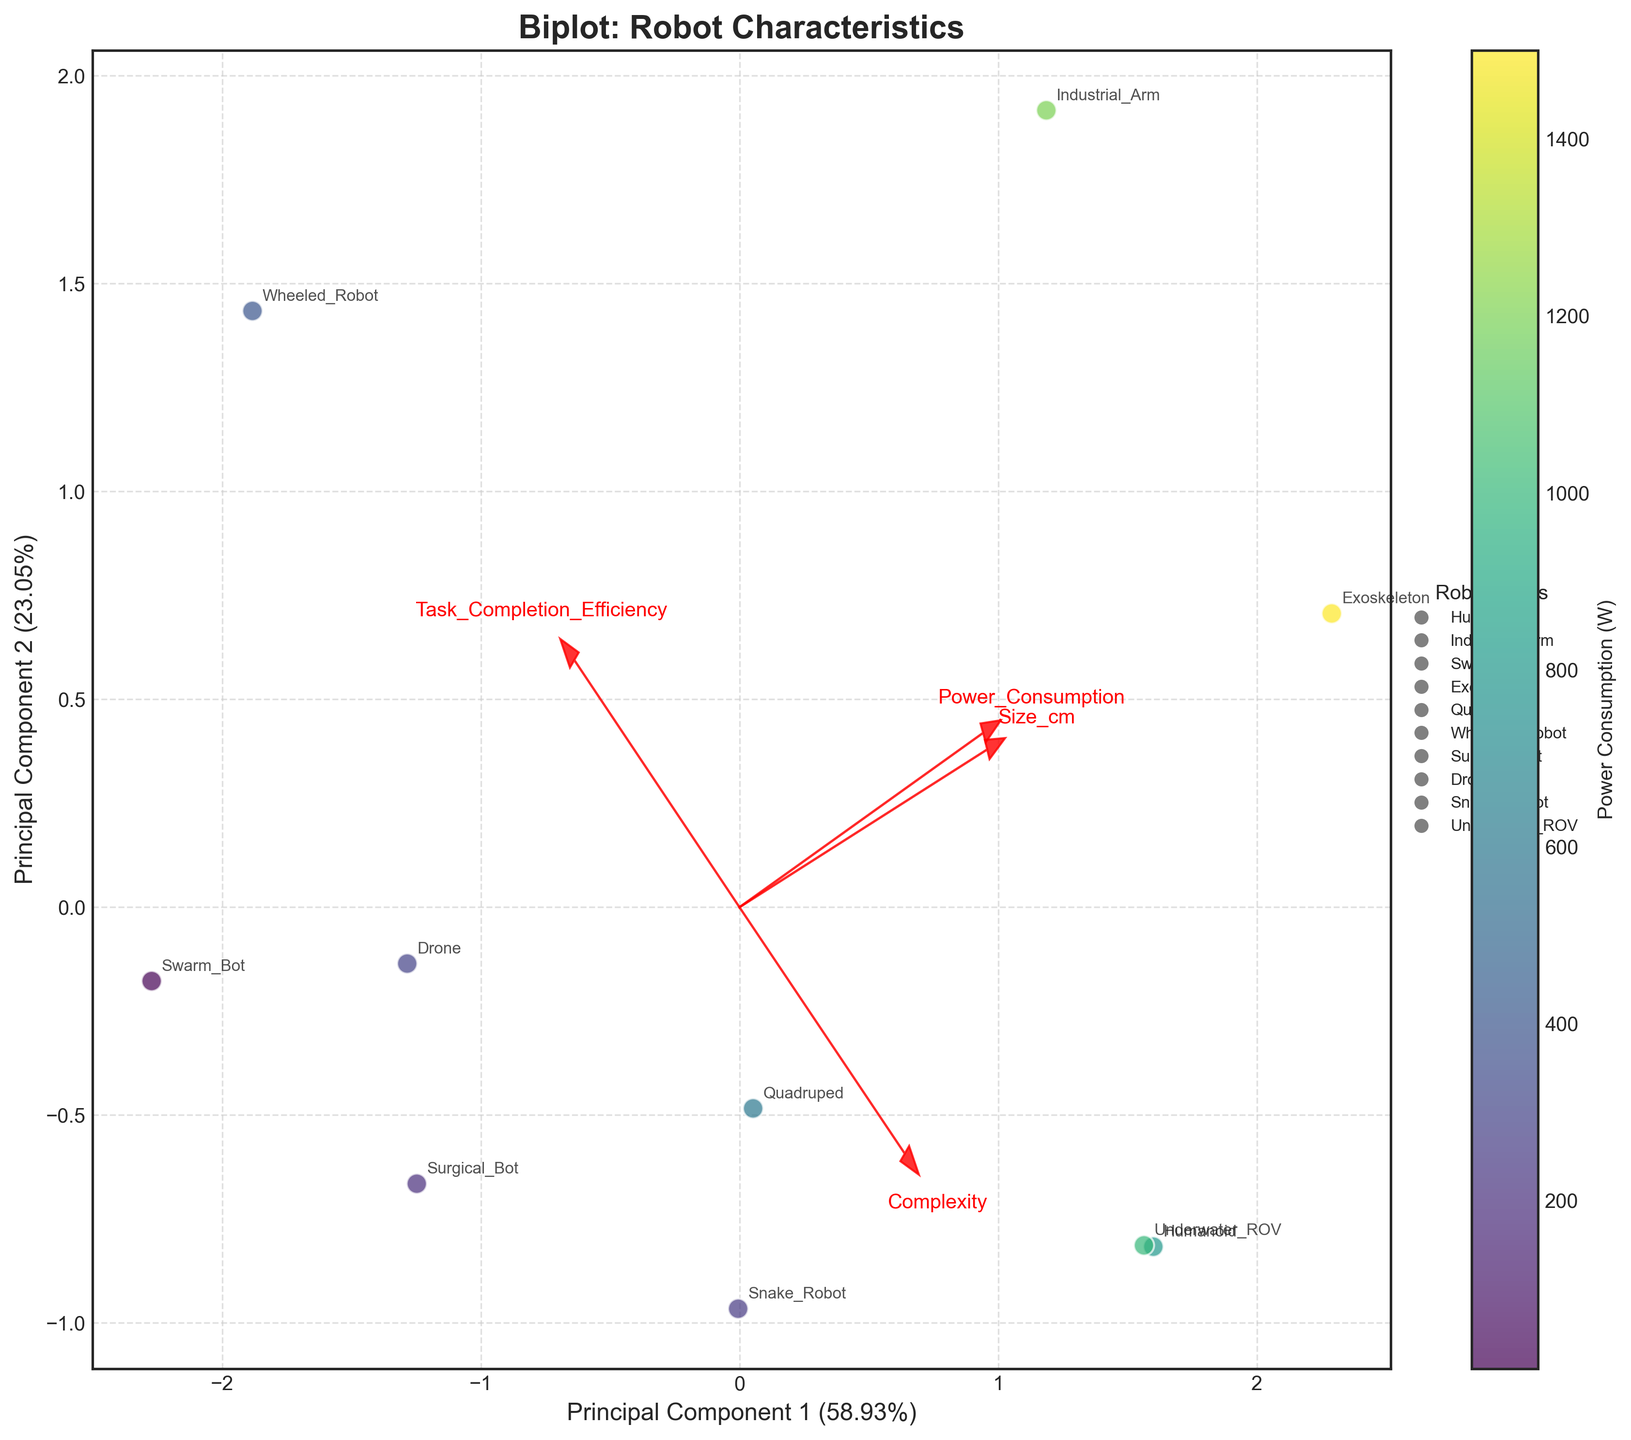How many different robot types are labeled on the plot? To answer this, count the distinct robot types annotated in the plot. Each unique robot type name corresponds to one distinct robot type.
Answer: 10 Which robot type has the highest task completion efficiency? Look for the robot type label closest to the vector representing 'Task_Completion_Efficiency,' which points in the direction where the values of this variable are higher.
Answer: Surgical_Bot What's the relationship between the size of a robot and its power consumption based on the biplot? Examine the direction and magnitude of the vectors for 'Size_cm' and 'Power_Consumption.' If they point in similar directions, there is a positive relationship; opposite directions indicate a negative relationship.
Answer: Positive relationship Do larger robots generally have higher complexity? Compare the directions of the 'Size_cm' and 'Complexity' vectors. If they point in the same general direction, it indicates that larger robots tend to have higher complexity; otherwise, they do not.
Answer: Yes, they do How are the 'Drone' and 'Underwater_ROV' positioned relative to each other on the plot? Find the plotted points for 'Drone' and 'Underwater_ROV' and compare their positions along Principal Component 1 and Principal Component 2.
Answer: Drone and Underwater_ROV are relatively far apart Which robot type appears to have the lowest power consumption? Refer to the color gradient on the scatter plot; the robot type with the lightest color (toward the bottom of the colorbar) has the lowest power consumption.
Answer: Swarm_Bot Does higher complexity correlate with better task completion efficiency? Look at the directions of the vectors for 'Complexity' and 'Task_Completion_Efficiency.' If they point in closely similar directions, there's a positive correlation.
Answer: No, they do not Which Principal Component explains more of the variance in the data? Examine the labels on the x-axis and y-axis, which indicate the percentage of variance explained by Principal Component 1 and Principal Component 2.
Answer: Principal Component 1 Are 'Humanoid' and 'Exoskeleton' similar in terms of their task completion efficiency and power consumption? Locate the points for 'Humanoid' and 'Exoskeleton' and compare their proximity concerning the task completion efficiency and power consumption vectors.
Answer: No, they are not similar 